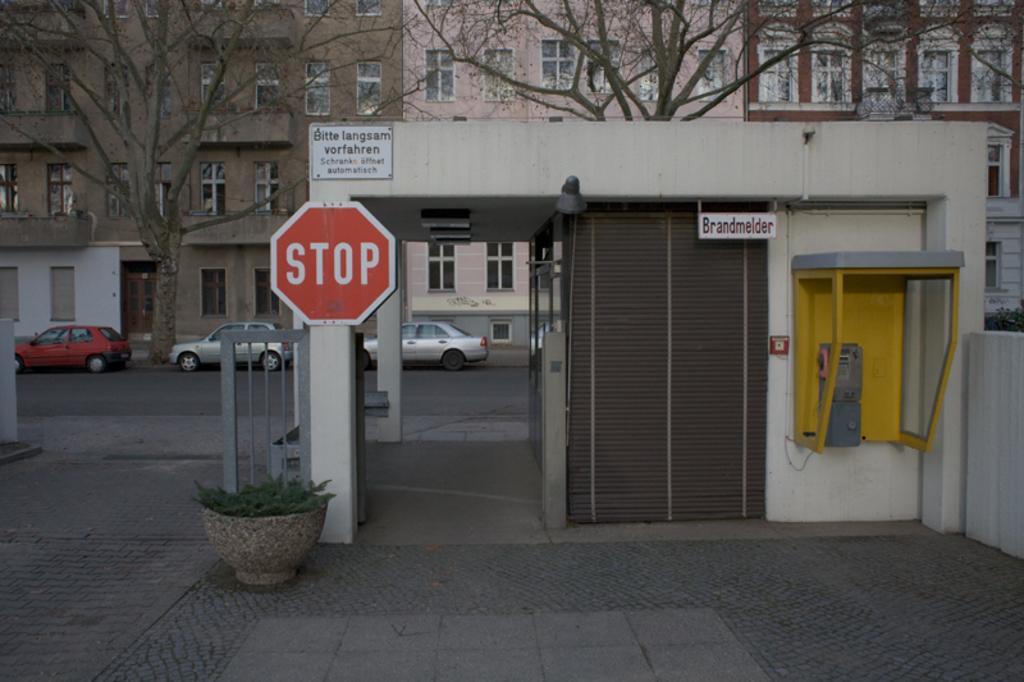Describe this image in one or two sentences. In this image we can see a plant, boards, shutter, pillars, wall, bare trees, and buildings. There are vehicles on the road. 